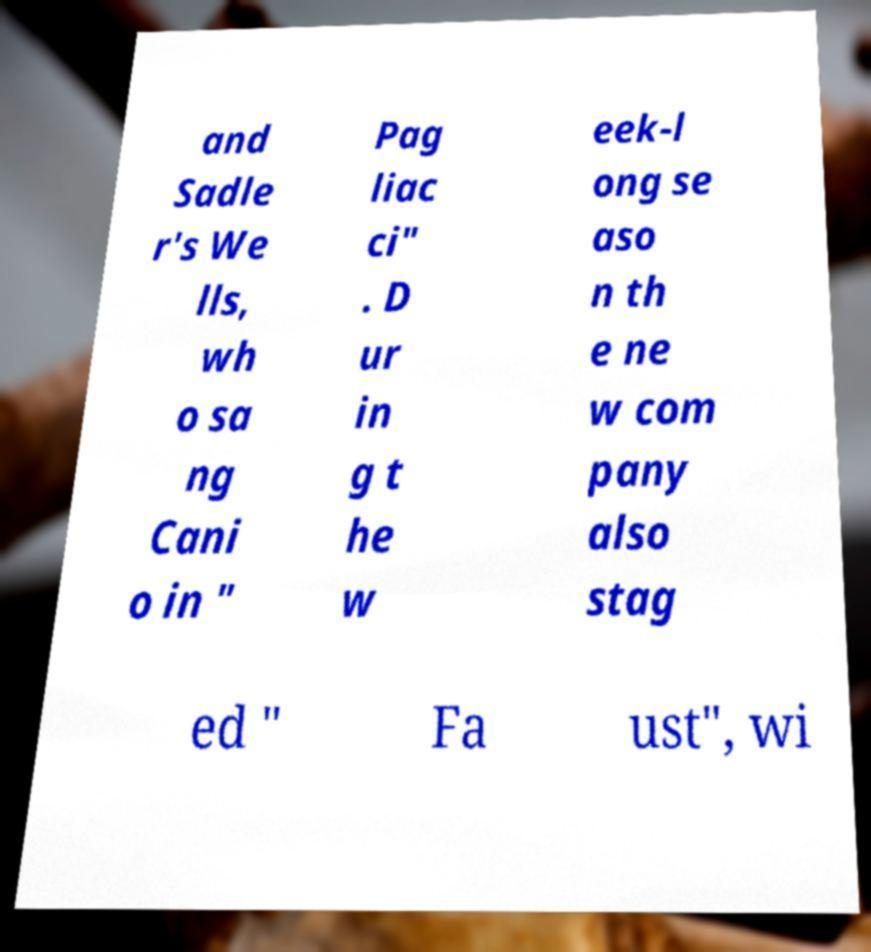Can you accurately transcribe the text from the provided image for me? and Sadle r's We lls, wh o sa ng Cani o in " Pag liac ci" . D ur in g t he w eek-l ong se aso n th e ne w com pany also stag ed " Fa ust", wi 